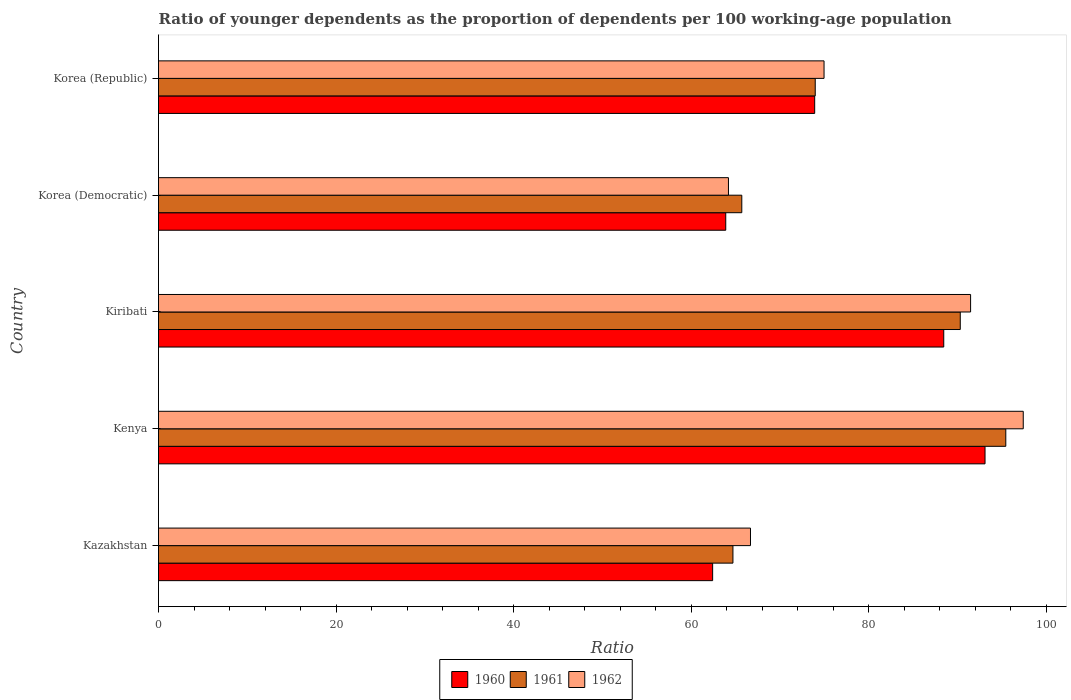How many groups of bars are there?
Your answer should be compact. 5. Are the number of bars per tick equal to the number of legend labels?
Give a very brief answer. Yes. How many bars are there on the 4th tick from the top?
Make the answer very short. 3. What is the label of the 4th group of bars from the top?
Provide a succinct answer. Kenya. What is the age dependency ratio(young) in 1961 in Kenya?
Offer a terse response. 95.43. Across all countries, what is the maximum age dependency ratio(young) in 1961?
Provide a short and direct response. 95.43. Across all countries, what is the minimum age dependency ratio(young) in 1961?
Provide a succinct answer. 64.7. In which country was the age dependency ratio(young) in 1961 maximum?
Make the answer very short. Kenya. In which country was the age dependency ratio(young) in 1961 minimum?
Your answer should be compact. Kazakhstan. What is the total age dependency ratio(young) in 1960 in the graph?
Keep it short and to the point. 381.74. What is the difference between the age dependency ratio(young) in 1962 in Kenya and that in Korea (Republic)?
Give a very brief answer. 22.44. What is the difference between the age dependency ratio(young) in 1960 in Kenya and the age dependency ratio(young) in 1962 in Korea (Republic)?
Offer a very short reply. 18.13. What is the average age dependency ratio(young) in 1961 per country?
Your answer should be compact. 78.02. What is the difference between the age dependency ratio(young) in 1962 and age dependency ratio(young) in 1961 in Kazakhstan?
Ensure brevity in your answer.  1.98. What is the ratio of the age dependency ratio(young) in 1961 in Kenya to that in Korea (Democratic)?
Provide a short and direct response. 1.45. Is the difference between the age dependency ratio(young) in 1962 in Kazakhstan and Kenya greater than the difference between the age dependency ratio(young) in 1961 in Kazakhstan and Kenya?
Offer a very short reply. Yes. What is the difference between the highest and the second highest age dependency ratio(young) in 1960?
Your answer should be very brief. 4.65. What is the difference between the highest and the lowest age dependency ratio(young) in 1960?
Ensure brevity in your answer.  30.68. Is the sum of the age dependency ratio(young) in 1962 in Kiribati and Korea (Democratic) greater than the maximum age dependency ratio(young) in 1961 across all countries?
Give a very brief answer. Yes. What does the 2nd bar from the bottom in Kenya represents?
Provide a succinct answer. 1961. How many bars are there?
Your answer should be very brief. 15. Are all the bars in the graph horizontal?
Provide a succinct answer. Yes. What is the difference between two consecutive major ticks on the X-axis?
Your response must be concise. 20. Does the graph contain grids?
Offer a terse response. No. Where does the legend appear in the graph?
Keep it short and to the point. Bottom center. What is the title of the graph?
Keep it short and to the point. Ratio of younger dependents as the proportion of dependents per 100 working-age population. What is the label or title of the X-axis?
Make the answer very short. Ratio. What is the Ratio in 1960 in Kazakhstan?
Provide a succinct answer. 62.41. What is the Ratio of 1961 in Kazakhstan?
Provide a short and direct response. 64.7. What is the Ratio of 1962 in Kazakhstan?
Provide a short and direct response. 66.67. What is the Ratio of 1960 in Kenya?
Offer a very short reply. 93.09. What is the Ratio of 1961 in Kenya?
Make the answer very short. 95.43. What is the Ratio in 1962 in Kenya?
Make the answer very short. 97.4. What is the Ratio of 1960 in Kiribati?
Provide a short and direct response. 88.44. What is the Ratio in 1961 in Kiribati?
Keep it short and to the point. 90.3. What is the Ratio in 1962 in Kiribati?
Your response must be concise. 91.47. What is the Ratio in 1960 in Korea (Democratic)?
Offer a very short reply. 63.89. What is the Ratio in 1961 in Korea (Democratic)?
Keep it short and to the point. 65.7. What is the Ratio in 1962 in Korea (Democratic)?
Your response must be concise. 64.19. What is the Ratio in 1960 in Korea (Republic)?
Keep it short and to the point. 73.91. What is the Ratio in 1961 in Korea (Republic)?
Keep it short and to the point. 73.97. What is the Ratio in 1962 in Korea (Republic)?
Your response must be concise. 74.96. Across all countries, what is the maximum Ratio in 1960?
Your answer should be very brief. 93.09. Across all countries, what is the maximum Ratio in 1961?
Provide a short and direct response. 95.43. Across all countries, what is the maximum Ratio of 1962?
Give a very brief answer. 97.4. Across all countries, what is the minimum Ratio of 1960?
Provide a succinct answer. 62.41. Across all countries, what is the minimum Ratio of 1961?
Offer a very short reply. 64.7. Across all countries, what is the minimum Ratio in 1962?
Ensure brevity in your answer.  64.19. What is the total Ratio of 1960 in the graph?
Ensure brevity in your answer.  381.74. What is the total Ratio in 1961 in the graph?
Offer a very short reply. 390.1. What is the total Ratio of 1962 in the graph?
Your answer should be very brief. 394.69. What is the difference between the Ratio of 1960 in Kazakhstan and that in Kenya?
Keep it short and to the point. -30.68. What is the difference between the Ratio of 1961 in Kazakhstan and that in Kenya?
Offer a terse response. -30.73. What is the difference between the Ratio of 1962 in Kazakhstan and that in Kenya?
Provide a succinct answer. -30.72. What is the difference between the Ratio in 1960 in Kazakhstan and that in Kiribati?
Keep it short and to the point. -26.03. What is the difference between the Ratio in 1961 in Kazakhstan and that in Kiribati?
Provide a short and direct response. -25.61. What is the difference between the Ratio in 1962 in Kazakhstan and that in Kiribati?
Your answer should be compact. -24.79. What is the difference between the Ratio in 1960 in Kazakhstan and that in Korea (Democratic)?
Your answer should be very brief. -1.48. What is the difference between the Ratio in 1961 in Kazakhstan and that in Korea (Democratic)?
Offer a terse response. -1. What is the difference between the Ratio of 1962 in Kazakhstan and that in Korea (Democratic)?
Ensure brevity in your answer.  2.48. What is the difference between the Ratio in 1960 in Kazakhstan and that in Korea (Republic)?
Offer a terse response. -11.49. What is the difference between the Ratio in 1961 in Kazakhstan and that in Korea (Republic)?
Offer a very short reply. -9.27. What is the difference between the Ratio in 1962 in Kazakhstan and that in Korea (Republic)?
Your response must be concise. -8.29. What is the difference between the Ratio of 1960 in Kenya and that in Kiribati?
Offer a terse response. 4.65. What is the difference between the Ratio of 1961 in Kenya and that in Kiribati?
Your answer should be very brief. 5.13. What is the difference between the Ratio in 1962 in Kenya and that in Kiribati?
Provide a short and direct response. 5.93. What is the difference between the Ratio in 1960 in Kenya and that in Korea (Democratic)?
Give a very brief answer. 29.2. What is the difference between the Ratio of 1961 in Kenya and that in Korea (Democratic)?
Your answer should be compact. 29.74. What is the difference between the Ratio of 1962 in Kenya and that in Korea (Democratic)?
Offer a terse response. 33.21. What is the difference between the Ratio in 1960 in Kenya and that in Korea (Republic)?
Offer a very short reply. 19.19. What is the difference between the Ratio of 1961 in Kenya and that in Korea (Republic)?
Your answer should be compact. 21.46. What is the difference between the Ratio in 1962 in Kenya and that in Korea (Republic)?
Offer a very short reply. 22.44. What is the difference between the Ratio in 1960 in Kiribati and that in Korea (Democratic)?
Offer a terse response. 24.55. What is the difference between the Ratio in 1961 in Kiribati and that in Korea (Democratic)?
Ensure brevity in your answer.  24.61. What is the difference between the Ratio in 1962 in Kiribati and that in Korea (Democratic)?
Make the answer very short. 27.27. What is the difference between the Ratio of 1960 in Kiribati and that in Korea (Republic)?
Ensure brevity in your answer.  14.54. What is the difference between the Ratio in 1961 in Kiribati and that in Korea (Republic)?
Your response must be concise. 16.34. What is the difference between the Ratio in 1962 in Kiribati and that in Korea (Republic)?
Provide a short and direct response. 16.51. What is the difference between the Ratio in 1960 in Korea (Democratic) and that in Korea (Republic)?
Give a very brief answer. -10.02. What is the difference between the Ratio of 1961 in Korea (Democratic) and that in Korea (Republic)?
Offer a terse response. -8.27. What is the difference between the Ratio in 1962 in Korea (Democratic) and that in Korea (Republic)?
Give a very brief answer. -10.77. What is the difference between the Ratio of 1960 in Kazakhstan and the Ratio of 1961 in Kenya?
Your answer should be compact. -33.02. What is the difference between the Ratio of 1960 in Kazakhstan and the Ratio of 1962 in Kenya?
Keep it short and to the point. -34.99. What is the difference between the Ratio of 1961 in Kazakhstan and the Ratio of 1962 in Kenya?
Your answer should be very brief. -32.7. What is the difference between the Ratio in 1960 in Kazakhstan and the Ratio in 1961 in Kiribati?
Your answer should be compact. -27.89. What is the difference between the Ratio of 1960 in Kazakhstan and the Ratio of 1962 in Kiribati?
Give a very brief answer. -29.05. What is the difference between the Ratio in 1961 in Kazakhstan and the Ratio in 1962 in Kiribati?
Offer a very short reply. -26.77. What is the difference between the Ratio in 1960 in Kazakhstan and the Ratio in 1961 in Korea (Democratic)?
Ensure brevity in your answer.  -3.28. What is the difference between the Ratio in 1960 in Kazakhstan and the Ratio in 1962 in Korea (Democratic)?
Provide a succinct answer. -1.78. What is the difference between the Ratio of 1961 in Kazakhstan and the Ratio of 1962 in Korea (Democratic)?
Offer a terse response. 0.51. What is the difference between the Ratio in 1960 in Kazakhstan and the Ratio in 1961 in Korea (Republic)?
Offer a very short reply. -11.56. What is the difference between the Ratio in 1960 in Kazakhstan and the Ratio in 1962 in Korea (Republic)?
Provide a succinct answer. -12.55. What is the difference between the Ratio in 1961 in Kazakhstan and the Ratio in 1962 in Korea (Republic)?
Provide a short and direct response. -10.26. What is the difference between the Ratio in 1960 in Kenya and the Ratio in 1961 in Kiribati?
Your answer should be compact. 2.79. What is the difference between the Ratio of 1960 in Kenya and the Ratio of 1962 in Kiribati?
Provide a succinct answer. 1.62. What is the difference between the Ratio of 1961 in Kenya and the Ratio of 1962 in Kiribati?
Your answer should be compact. 3.96. What is the difference between the Ratio in 1960 in Kenya and the Ratio in 1961 in Korea (Democratic)?
Make the answer very short. 27.4. What is the difference between the Ratio of 1960 in Kenya and the Ratio of 1962 in Korea (Democratic)?
Your answer should be compact. 28.9. What is the difference between the Ratio of 1961 in Kenya and the Ratio of 1962 in Korea (Democratic)?
Your answer should be compact. 31.24. What is the difference between the Ratio of 1960 in Kenya and the Ratio of 1961 in Korea (Republic)?
Keep it short and to the point. 19.12. What is the difference between the Ratio of 1960 in Kenya and the Ratio of 1962 in Korea (Republic)?
Give a very brief answer. 18.13. What is the difference between the Ratio of 1961 in Kenya and the Ratio of 1962 in Korea (Republic)?
Provide a short and direct response. 20.47. What is the difference between the Ratio in 1960 in Kiribati and the Ratio in 1961 in Korea (Democratic)?
Keep it short and to the point. 22.75. What is the difference between the Ratio of 1960 in Kiribati and the Ratio of 1962 in Korea (Democratic)?
Offer a terse response. 24.25. What is the difference between the Ratio of 1961 in Kiribati and the Ratio of 1962 in Korea (Democratic)?
Offer a terse response. 26.11. What is the difference between the Ratio in 1960 in Kiribati and the Ratio in 1961 in Korea (Republic)?
Offer a terse response. 14.47. What is the difference between the Ratio of 1960 in Kiribati and the Ratio of 1962 in Korea (Republic)?
Ensure brevity in your answer.  13.48. What is the difference between the Ratio of 1961 in Kiribati and the Ratio of 1962 in Korea (Republic)?
Your answer should be very brief. 15.34. What is the difference between the Ratio in 1960 in Korea (Democratic) and the Ratio in 1961 in Korea (Republic)?
Your answer should be compact. -10.08. What is the difference between the Ratio in 1960 in Korea (Democratic) and the Ratio in 1962 in Korea (Republic)?
Offer a terse response. -11.07. What is the difference between the Ratio in 1961 in Korea (Democratic) and the Ratio in 1962 in Korea (Republic)?
Offer a very short reply. -9.26. What is the average Ratio in 1960 per country?
Offer a terse response. 76.35. What is the average Ratio of 1961 per country?
Offer a terse response. 78.02. What is the average Ratio of 1962 per country?
Ensure brevity in your answer.  78.94. What is the difference between the Ratio in 1960 and Ratio in 1961 in Kazakhstan?
Make the answer very short. -2.29. What is the difference between the Ratio of 1960 and Ratio of 1962 in Kazakhstan?
Keep it short and to the point. -4.26. What is the difference between the Ratio of 1961 and Ratio of 1962 in Kazakhstan?
Keep it short and to the point. -1.98. What is the difference between the Ratio in 1960 and Ratio in 1961 in Kenya?
Give a very brief answer. -2.34. What is the difference between the Ratio in 1960 and Ratio in 1962 in Kenya?
Give a very brief answer. -4.31. What is the difference between the Ratio in 1961 and Ratio in 1962 in Kenya?
Ensure brevity in your answer.  -1.97. What is the difference between the Ratio of 1960 and Ratio of 1961 in Kiribati?
Your response must be concise. -1.86. What is the difference between the Ratio in 1960 and Ratio in 1962 in Kiribati?
Keep it short and to the point. -3.02. What is the difference between the Ratio of 1961 and Ratio of 1962 in Kiribati?
Keep it short and to the point. -1.16. What is the difference between the Ratio in 1960 and Ratio in 1961 in Korea (Democratic)?
Your response must be concise. -1.81. What is the difference between the Ratio in 1960 and Ratio in 1962 in Korea (Democratic)?
Provide a short and direct response. -0.3. What is the difference between the Ratio in 1961 and Ratio in 1962 in Korea (Democratic)?
Offer a terse response. 1.5. What is the difference between the Ratio in 1960 and Ratio in 1961 in Korea (Republic)?
Offer a terse response. -0.06. What is the difference between the Ratio in 1960 and Ratio in 1962 in Korea (Republic)?
Your answer should be compact. -1.05. What is the difference between the Ratio of 1961 and Ratio of 1962 in Korea (Republic)?
Make the answer very short. -0.99. What is the ratio of the Ratio of 1960 in Kazakhstan to that in Kenya?
Offer a terse response. 0.67. What is the ratio of the Ratio of 1961 in Kazakhstan to that in Kenya?
Your answer should be very brief. 0.68. What is the ratio of the Ratio of 1962 in Kazakhstan to that in Kenya?
Keep it short and to the point. 0.68. What is the ratio of the Ratio of 1960 in Kazakhstan to that in Kiribati?
Your answer should be compact. 0.71. What is the ratio of the Ratio of 1961 in Kazakhstan to that in Kiribati?
Give a very brief answer. 0.72. What is the ratio of the Ratio in 1962 in Kazakhstan to that in Kiribati?
Provide a short and direct response. 0.73. What is the ratio of the Ratio in 1960 in Kazakhstan to that in Korea (Democratic)?
Your answer should be very brief. 0.98. What is the ratio of the Ratio in 1962 in Kazakhstan to that in Korea (Democratic)?
Make the answer very short. 1.04. What is the ratio of the Ratio of 1960 in Kazakhstan to that in Korea (Republic)?
Your answer should be compact. 0.84. What is the ratio of the Ratio in 1961 in Kazakhstan to that in Korea (Republic)?
Provide a short and direct response. 0.87. What is the ratio of the Ratio in 1962 in Kazakhstan to that in Korea (Republic)?
Provide a short and direct response. 0.89. What is the ratio of the Ratio of 1960 in Kenya to that in Kiribati?
Ensure brevity in your answer.  1.05. What is the ratio of the Ratio of 1961 in Kenya to that in Kiribati?
Keep it short and to the point. 1.06. What is the ratio of the Ratio of 1962 in Kenya to that in Kiribati?
Your answer should be compact. 1.06. What is the ratio of the Ratio of 1960 in Kenya to that in Korea (Democratic)?
Provide a short and direct response. 1.46. What is the ratio of the Ratio of 1961 in Kenya to that in Korea (Democratic)?
Offer a very short reply. 1.45. What is the ratio of the Ratio of 1962 in Kenya to that in Korea (Democratic)?
Your answer should be very brief. 1.52. What is the ratio of the Ratio of 1960 in Kenya to that in Korea (Republic)?
Give a very brief answer. 1.26. What is the ratio of the Ratio in 1961 in Kenya to that in Korea (Republic)?
Offer a terse response. 1.29. What is the ratio of the Ratio in 1962 in Kenya to that in Korea (Republic)?
Offer a very short reply. 1.3. What is the ratio of the Ratio in 1960 in Kiribati to that in Korea (Democratic)?
Your answer should be compact. 1.38. What is the ratio of the Ratio of 1961 in Kiribati to that in Korea (Democratic)?
Your response must be concise. 1.37. What is the ratio of the Ratio of 1962 in Kiribati to that in Korea (Democratic)?
Keep it short and to the point. 1.42. What is the ratio of the Ratio in 1960 in Kiribati to that in Korea (Republic)?
Provide a succinct answer. 1.2. What is the ratio of the Ratio of 1961 in Kiribati to that in Korea (Republic)?
Offer a terse response. 1.22. What is the ratio of the Ratio of 1962 in Kiribati to that in Korea (Republic)?
Offer a terse response. 1.22. What is the ratio of the Ratio in 1960 in Korea (Democratic) to that in Korea (Republic)?
Ensure brevity in your answer.  0.86. What is the ratio of the Ratio of 1961 in Korea (Democratic) to that in Korea (Republic)?
Offer a very short reply. 0.89. What is the ratio of the Ratio of 1962 in Korea (Democratic) to that in Korea (Republic)?
Give a very brief answer. 0.86. What is the difference between the highest and the second highest Ratio in 1960?
Provide a succinct answer. 4.65. What is the difference between the highest and the second highest Ratio of 1961?
Offer a terse response. 5.13. What is the difference between the highest and the second highest Ratio of 1962?
Provide a succinct answer. 5.93. What is the difference between the highest and the lowest Ratio in 1960?
Your response must be concise. 30.68. What is the difference between the highest and the lowest Ratio of 1961?
Provide a succinct answer. 30.73. What is the difference between the highest and the lowest Ratio of 1962?
Make the answer very short. 33.21. 